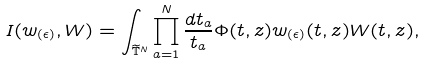Convert formula to latex. <formula><loc_0><loc_0><loc_500><loc_500>I ( w _ { ( \epsilon ) } , W ) = \int _ { \widetilde { \mathbb { T } } ^ { N } } \prod _ { a = 1 } ^ { N } \frac { d t _ { a } } { t _ { a } } \Phi ( t , z ) w _ { ( \epsilon ) } ( t , z ) W ( t , z ) ,</formula> 